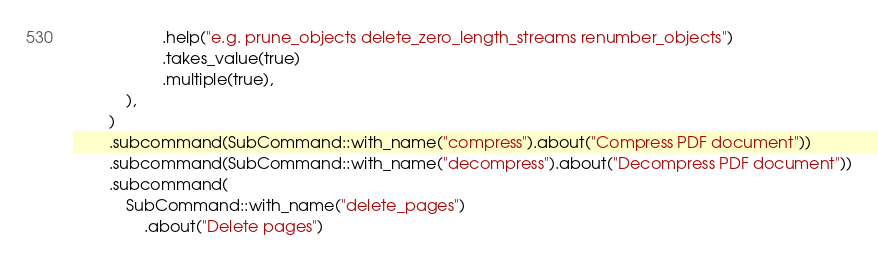Convert code to text. <code><loc_0><loc_0><loc_500><loc_500><_Rust_>					.help("e.g. prune_objects delete_zero_length_streams renumber_objects")
					.takes_value(true)
					.multiple(true),
			),
		)
		.subcommand(SubCommand::with_name("compress").about("Compress PDF document"))
		.subcommand(SubCommand::with_name("decompress").about("Decompress PDF document"))
		.subcommand(
			SubCommand::with_name("delete_pages")
				.about("Delete pages")</code> 